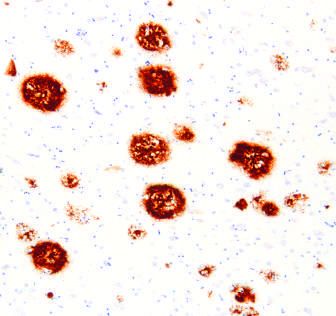s peptide present in the core of the plaques as well as in the surrounding region?
Answer the question using a single word or phrase. Yes 